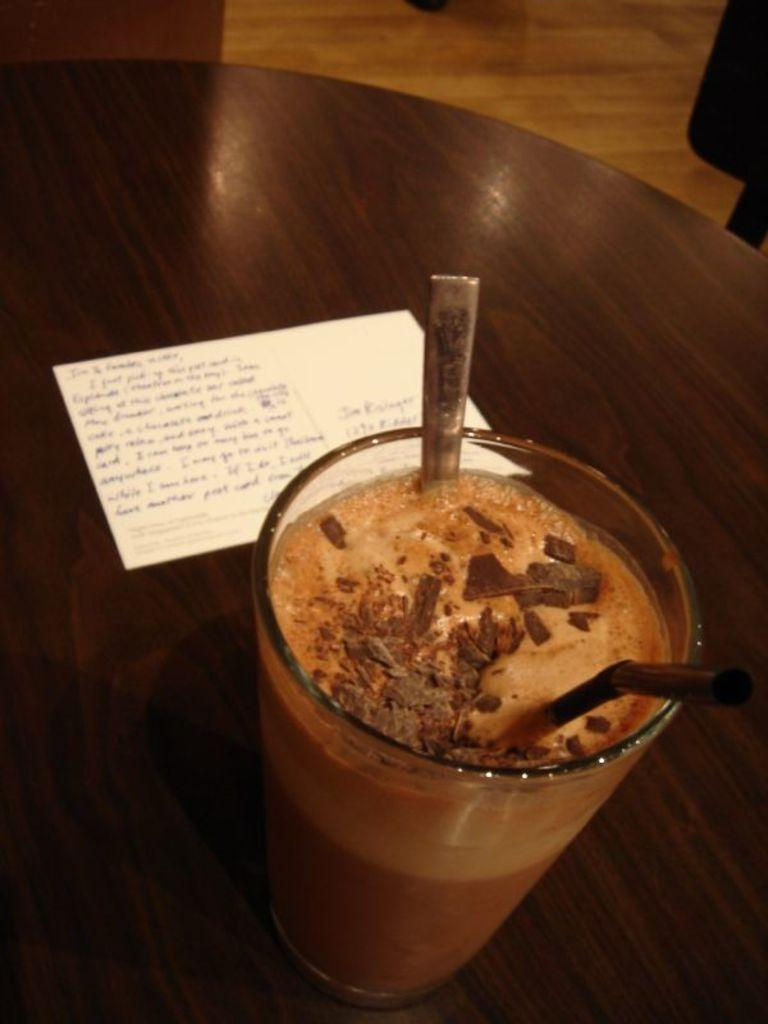What is inside the glass that is visible in the image? There is a glass with liquid in the image. What utensils are present in the glass? There is a straw and a spoon in the glass. Where is the glass located? The glass is on a table. What else is on the table besides the glass? There is a paper on the table. What type of flooring is visible in the image? The table is on a wooden floor. How much dust can be seen on the glass in the image? There is no mention of dust in the image, so it cannot be determined how much dust is present. 